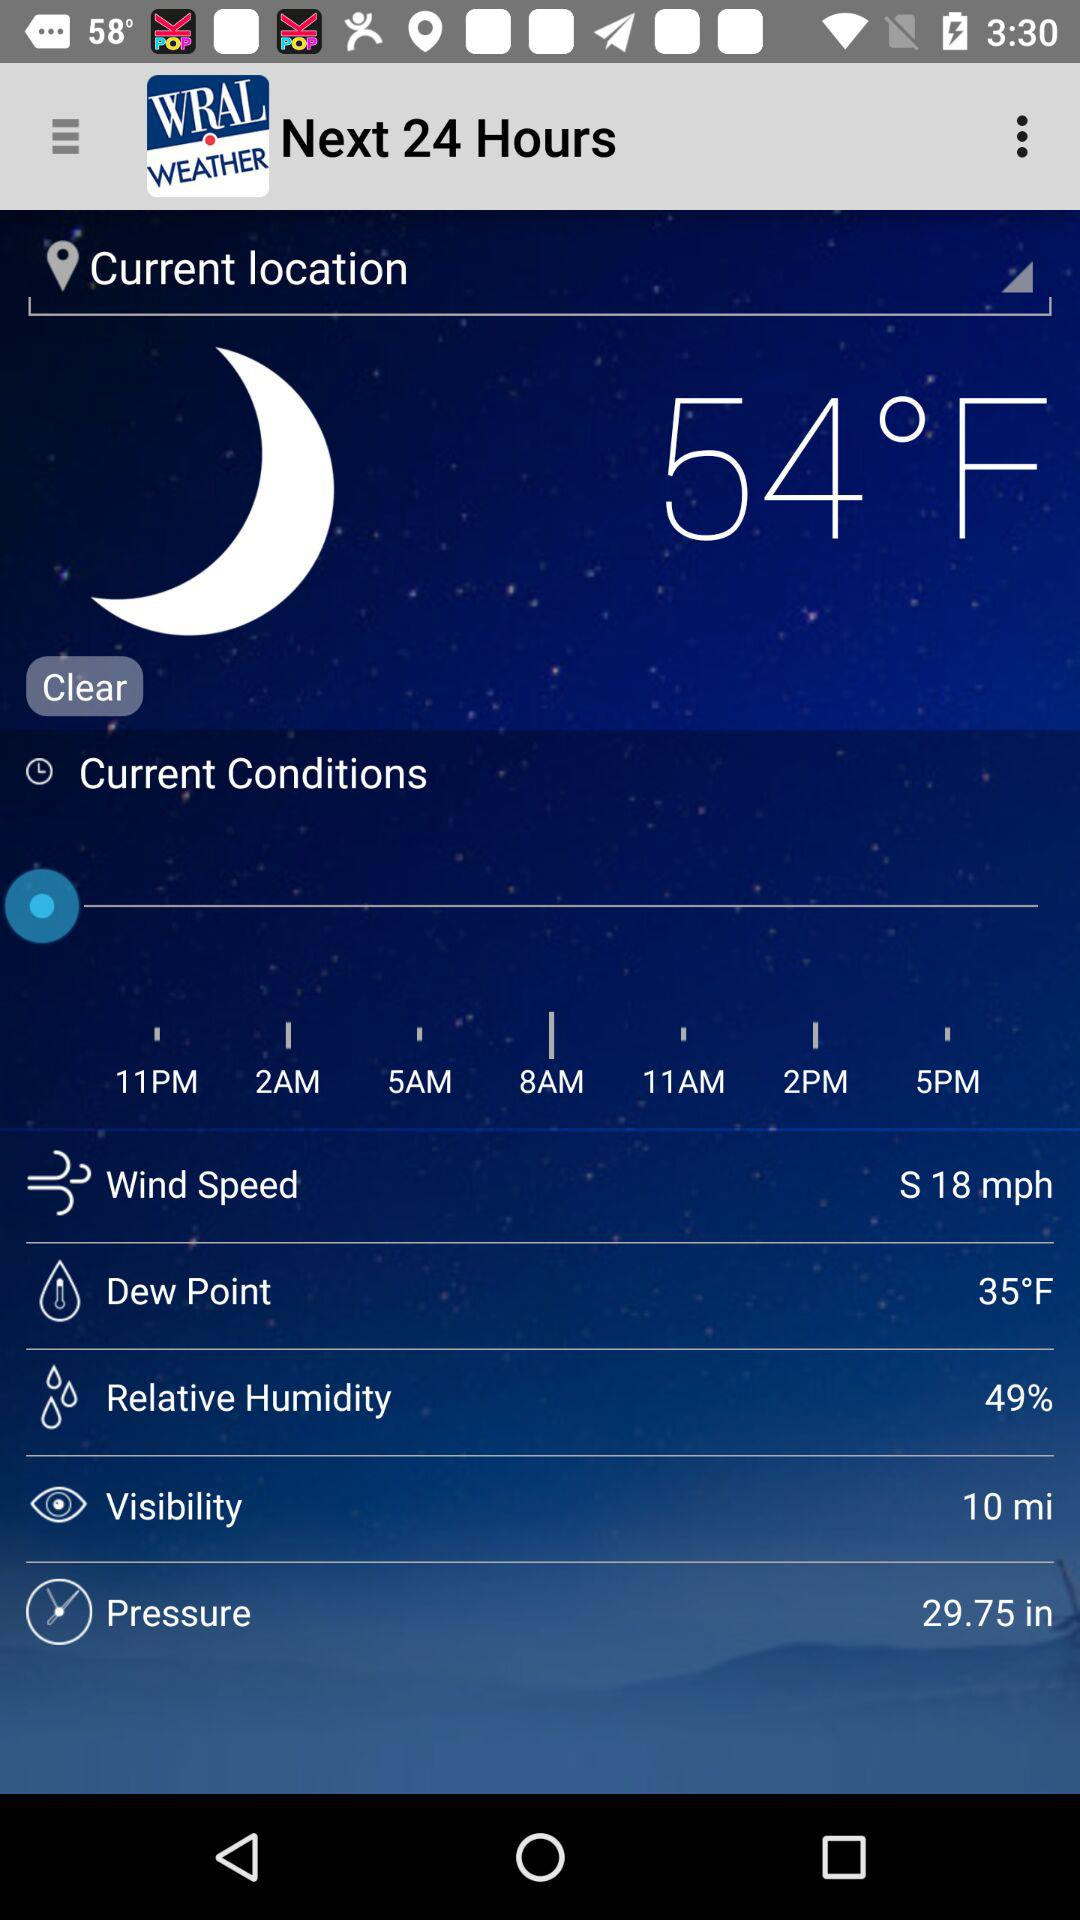What is the temperature? The temperature is 54 °F. 